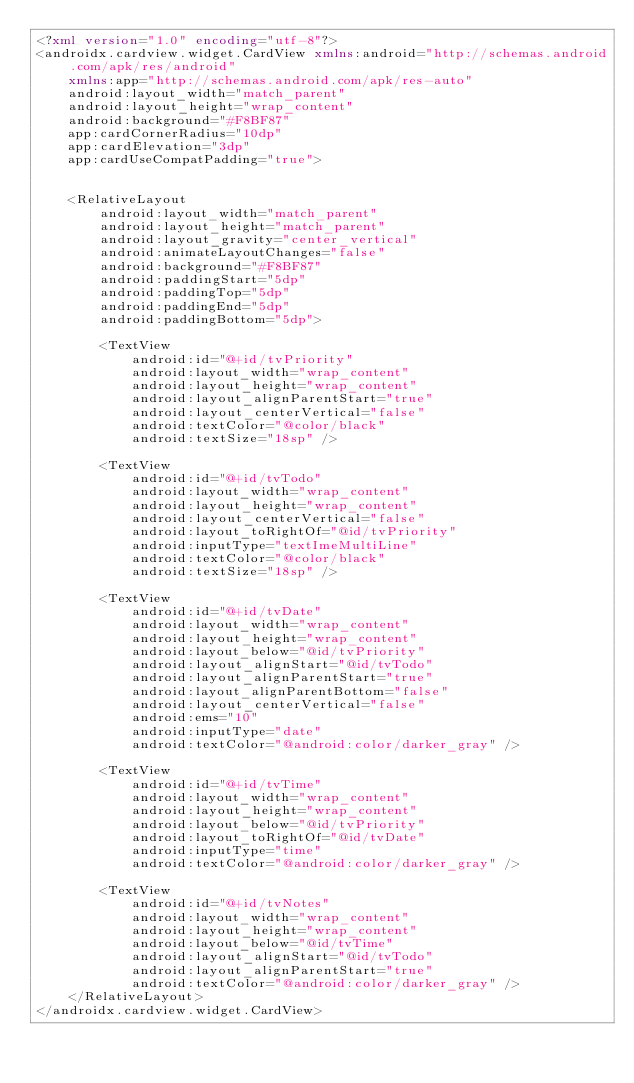<code> <loc_0><loc_0><loc_500><loc_500><_XML_><?xml version="1.0" encoding="utf-8"?>
<androidx.cardview.widget.CardView xmlns:android="http://schemas.android.com/apk/res/android"
    xmlns:app="http://schemas.android.com/apk/res-auto"
    android:layout_width="match_parent"
    android:layout_height="wrap_content"
    android:background="#F8BF87"
    app:cardCornerRadius="10dp"
    app:cardElevation="3dp"
    app:cardUseCompatPadding="true">


    <RelativeLayout
        android:layout_width="match_parent"
        android:layout_height="match_parent"
        android:layout_gravity="center_vertical"
        android:animateLayoutChanges="false"
        android:background="#F8BF87"
        android:paddingStart="5dp"
        android:paddingTop="5dp"
        android:paddingEnd="5dp"
        android:paddingBottom="5dp">

        <TextView
            android:id="@+id/tvPriority"
            android:layout_width="wrap_content"
            android:layout_height="wrap_content"
            android:layout_alignParentStart="true"
            android:layout_centerVertical="false"
            android:textColor="@color/black"
            android:textSize="18sp" />

        <TextView
            android:id="@+id/tvTodo"
            android:layout_width="wrap_content"
            android:layout_height="wrap_content"
            android:layout_centerVertical="false"
            android:layout_toRightOf="@id/tvPriority"
            android:inputType="textImeMultiLine"
            android:textColor="@color/black"
            android:textSize="18sp" />

        <TextView
            android:id="@+id/tvDate"
            android:layout_width="wrap_content"
            android:layout_height="wrap_content"
            android:layout_below="@id/tvPriority"
            android:layout_alignStart="@id/tvTodo"
            android:layout_alignParentStart="true"
            android:layout_alignParentBottom="false"
            android:layout_centerVertical="false"
            android:ems="10"
            android:inputType="date"
            android:textColor="@android:color/darker_gray" />

        <TextView
            android:id="@+id/tvTime"
            android:layout_width="wrap_content"
            android:layout_height="wrap_content"
            android:layout_below="@id/tvPriority"
            android:layout_toRightOf="@id/tvDate"
            android:inputType="time"
            android:textColor="@android:color/darker_gray" />

        <TextView
            android:id="@+id/tvNotes"
            android:layout_width="wrap_content"
            android:layout_height="wrap_content"
            android:layout_below="@id/tvTime"
            android:layout_alignStart="@id/tvTodo"
            android:layout_alignParentStart="true"
            android:textColor="@android:color/darker_gray" />
    </RelativeLayout>
</androidx.cardview.widget.CardView></code> 